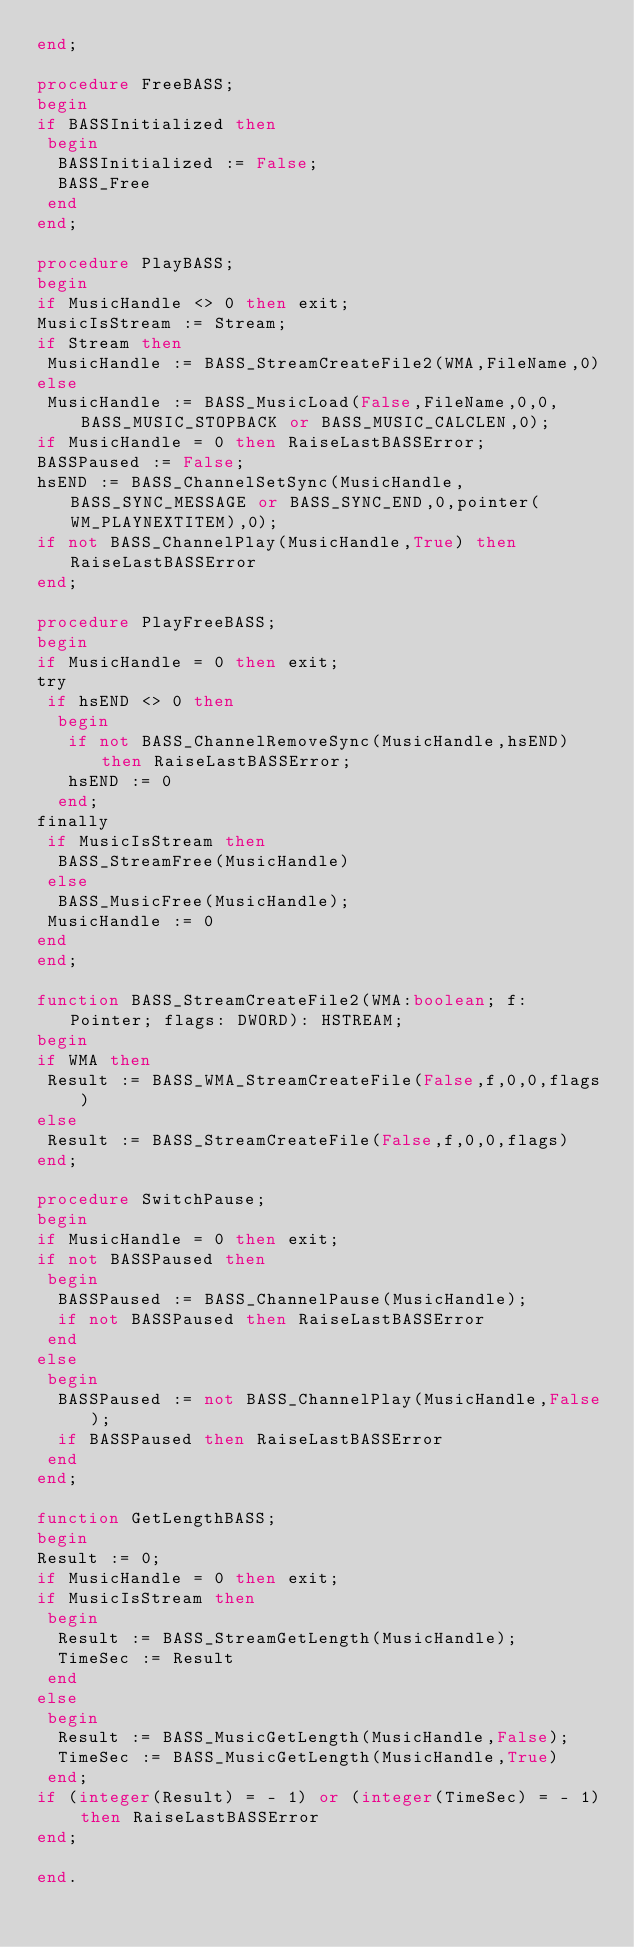Convert code to text. <code><loc_0><loc_0><loc_500><loc_500><_Pascal_>end;

procedure FreeBASS;
begin
if BASSInitialized then
 begin
  BASSInitialized := False;
  BASS_Free
 end
end;

procedure PlayBASS;
begin
if MusicHandle <> 0 then exit;
MusicIsStream := Stream;
if Stream then
 MusicHandle := BASS_StreamCreateFile2(WMA,FileName,0)
else
 MusicHandle := BASS_MusicLoad(False,FileName,0,0,BASS_MUSIC_STOPBACK or BASS_MUSIC_CALCLEN,0);
if MusicHandle = 0 then RaiseLastBASSError;
BASSPaused := False;
hsEND := BASS_ChannelSetSync(MusicHandle,BASS_SYNC_MESSAGE or BASS_SYNC_END,0,pointer(WM_PLAYNEXTITEM),0);
if not BASS_ChannelPlay(MusicHandle,True) then RaiseLastBASSError
end;

procedure PlayFreeBASS;
begin
if MusicHandle = 0 then exit;
try
 if hsEND <> 0 then
  begin
   if not BASS_ChannelRemoveSync(MusicHandle,hsEND) then RaiseLastBASSError;
   hsEND := 0
  end;
finally
 if MusicIsStream then
  BASS_StreamFree(MusicHandle)
 else
  BASS_MusicFree(MusicHandle);
 MusicHandle := 0
end
end;

function BASS_StreamCreateFile2(WMA:boolean; f: Pointer; flags: DWORD): HSTREAM;
begin
if WMA then
 Result := BASS_WMA_StreamCreateFile(False,f,0,0,flags)
else
 Result := BASS_StreamCreateFile(False,f,0,0,flags)
end;

procedure SwitchPause;
begin
if MusicHandle = 0 then exit;
if not BASSPaused then
 begin
  BASSPaused := BASS_ChannelPause(MusicHandle);
  if not BASSPaused then RaiseLastBASSError
 end
else
 begin
  BASSPaused := not BASS_ChannelPlay(MusicHandle,False);
  if BASSPaused then RaiseLastBASSError
 end
end;

function GetLengthBASS;
begin
Result := 0;
if MusicHandle = 0 then exit;
if MusicIsStream then
 begin
  Result := BASS_StreamGetLength(MusicHandle);
  TimeSec := Result
 end
else
 begin
  Result := BASS_MusicGetLength(MusicHandle,False);
  TimeSec := BASS_MusicGetLength(MusicHandle,True)
 end;
if (integer(Result) = - 1) or (integer(TimeSec) = - 1) then RaiseLastBASSError
end;

end.
</code> 